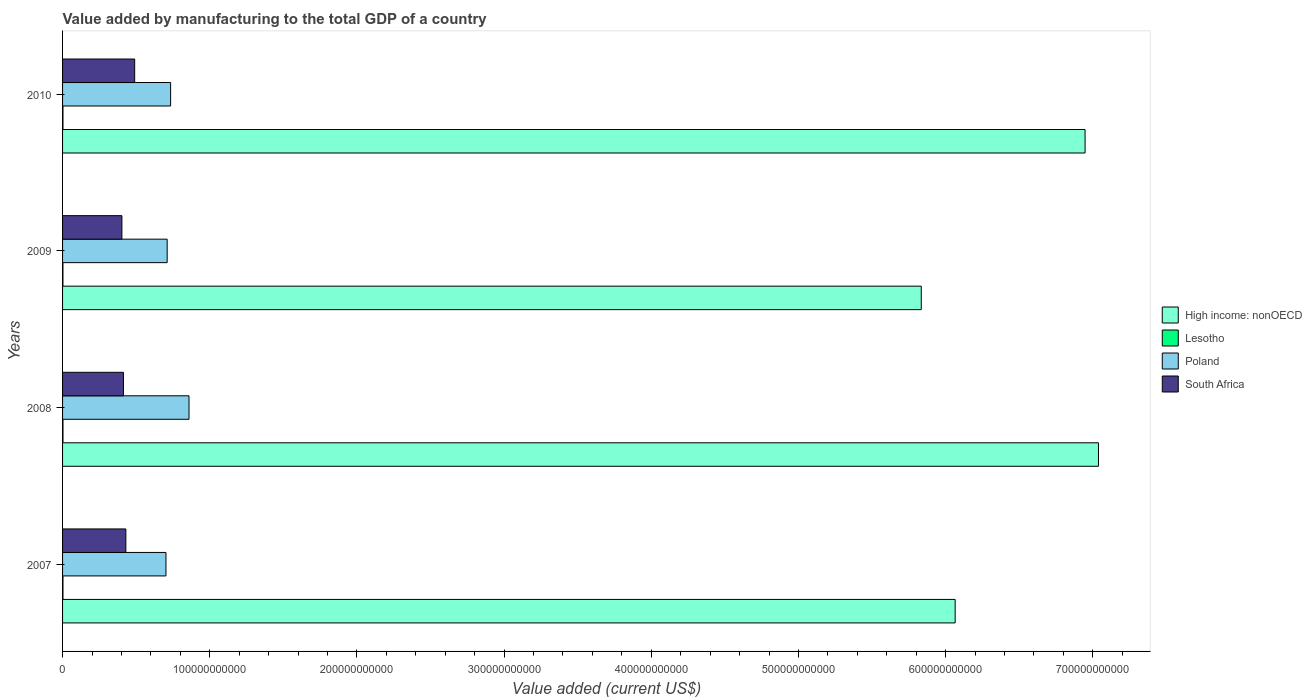How many groups of bars are there?
Make the answer very short. 4. Are the number of bars on each tick of the Y-axis equal?
Your answer should be compact. Yes. In how many cases, is the number of bars for a given year not equal to the number of legend labels?
Give a very brief answer. 0. What is the value added by manufacturing to the total GDP in South Africa in 2008?
Your response must be concise. 4.14e+1. Across all years, what is the maximum value added by manufacturing to the total GDP in High income: nonOECD?
Your answer should be very brief. 7.04e+11. Across all years, what is the minimum value added by manufacturing to the total GDP in Lesotho?
Offer a very short reply. 2.50e+08. In which year was the value added by manufacturing to the total GDP in Lesotho minimum?
Your answer should be very brief. 2009. What is the total value added by manufacturing to the total GDP in South Africa in the graph?
Your answer should be very brief. 1.74e+11. What is the difference between the value added by manufacturing to the total GDP in South Africa in 2009 and that in 2010?
Provide a short and direct response. -8.67e+09. What is the difference between the value added by manufacturing to the total GDP in South Africa in 2009 and the value added by manufacturing to the total GDP in High income: nonOECD in 2007?
Ensure brevity in your answer.  -5.66e+11. What is the average value added by manufacturing to the total GDP in Poland per year?
Your answer should be compact. 7.52e+1. In the year 2007, what is the difference between the value added by manufacturing to the total GDP in Poland and value added by manufacturing to the total GDP in Lesotho?
Keep it short and to the point. 7.00e+1. In how many years, is the value added by manufacturing to the total GDP in Poland greater than 500000000000 US$?
Your response must be concise. 0. What is the ratio of the value added by manufacturing to the total GDP in Lesotho in 2007 to that in 2008?
Make the answer very short. 0.98. Is the difference between the value added by manufacturing to the total GDP in Poland in 2008 and 2009 greater than the difference between the value added by manufacturing to the total GDP in Lesotho in 2008 and 2009?
Your answer should be compact. Yes. What is the difference between the highest and the second highest value added by manufacturing to the total GDP in High income: nonOECD?
Your answer should be compact. 9.09e+09. What is the difference between the highest and the lowest value added by manufacturing to the total GDP in High income: nonOECD?
Keep it short and to the point. 1.20e+11. What does the 1st bar from the top in 2007 represents?
Offer a very short reply. South Africa. What does the 2nd bar from the bottom in 2009 represents?
Ensure brevity in your answer.  Lesotho. Is it the case that in every year, the sum of the value added by manufacturing to the total GDP in High income: nonOECD and value added by manufacturing to the total GDP in Lesotho is greater than the value added by manufacturing to the total GDP in South Africa?
Provide a succinct answer. Yes. Are all the bars in the graph horizontal?
Offer a terse response. Yes. How many years are there in the graph?
Offer a very short reply. 4. What is the difference between two consecutive major ticks on the X-axis?
Offer a very short reply. 1.00e+11. Does the graph contain grids?
Your response must be concise. No. Where does the legend appear in the graph?
Provide a short and direct response. Center right. How many legend labels are there?
Make the answer very short. 4. What is the title of the graph?
Your answer should be compact. Value added by manufacturing to the total GDP of a country. What is the label or title of the X-axis?
Your response must be concise. Value added (current US$). What is the Value added (current US$) of High income: nonOECD in 2007?
Give a very brief answer. 6.07e+11. What is the Value added (current US$) in Lesotho in 2007?
Offer a very short reply. 2.78e+08. What is the Value added (current US$) of Poland in 2007?
Offer a terse response. 7.03e+1. What is the Value added (current US$) in South Africa in 2007?
Provide a succinct answer. 4.30e+1. What is the Value added (current US$) in High income: nonOECD in 2008?
Provide a succinct answer. 7.04e+11. What is the Value added (current US$) in Lesotho in 2008?
Provide a short and direct response. 2.85e+08. What is the Value added (current US$) of Poland in 2008?
Offer a very short reply. 8.59e+1. What is the Value added (current US$) in South Africa in 2008?
Offer a very short reply. 4.14e+1. What is the Value added (current US$) of High income: nonOECD in 2009?
Ensure brevity in your answer.  5.83e+11. What is the Value added (current US$) in Lesotho in 2009?
Give a very brief answer. 2.50e+08. What is the Value added (current US$) in Poland in 2009?
Your answer should be very brief. 7.11e+1. What is the Value added (current US$) of South Africa in 2009?
Ensure brevity in your answer.  4.03e+1. What is the Value added (current US$) of High income: nonOECD in 2010?
Give a very brief answer. 6.95e+11. What is the Value added (current US$) in Lesotho in 2010?
Offer a terse response. 2.76e+08. What is the Value added (current US$) in Poland in 2010?
Ensure brevity in your answer.  7.34e+1. What is the Value added (current US$) of South Africa in 2010?
Ensure brevity in your answer.  4.90e+1. Across all years, what is the maximum Value added (current US$) in High income: nonOECD?
Offer a terse response. 7.04e+11. Across all years, what is the maximum Value added (current US$) in Lesotho?
Provide a short and direct response. 2.85e+08. Across all years, what is the maximum Value added (current US$) of Poland?
Provide a succinct answer. 8.59e+1. Across all years, what is the maximum Value added (current US$) in South Africa?
Make the answer very short. 4.90e+1. Across all years, what is the minimum Value added (current US$) of High income: nonOECD?
Give a very brief answer. 5.83e+11. Across all years, what is the minimum Value added (current US$) in Lesotho?
Your response must be concise. 2.50e+08. Across all years, what is the minimum Value added (current US$) in Poland?
Offer a very short reply. 7.03e+1. Across all years, what is the minimum Value added (current US$) of South Africa?
Keep it short and to the point. 4.03e+1. What is the total Value added (current US$) of High income: nonOECD in the graph?
Keep it short and to the point. 2.59e+12. What is the total Value added (current US$) in Lesotho in the graph?
Your response must be concise. 1.09e+09. What is the total Value added (current US$) of Poland in the graph?
Your answer should be very brief. 3.01e+11. What is the total Value added (current US$) in South Africa in the graph?
Offer a very short reply. 1.74e+11. What is the difference between the Value added (current US$) of High income: nonOECD in 2007 and that in 2008?
Provide a succinct answer. -9.74e+1. What is the difference between the Value added (current US$) of Lesotho in 2007 and that in 2008?
Ensure brevity in your answer.  -6.76e+06. What is the difference between the Value added (current US$) of Poland in 2007 and that in 2008?
Make the answer very short. -1.57e+1. What is the difference between the Value added (current US$) in South Africa in 2007 and that in 2008?
Offer a very short reply. 1.64e+09. What is the difference between the Value added (current US$) of High income: nonOECD in 2007 and that in 2009?
Your answer should be compact. 2.30e+1. What is the difference between the Value added (current US$) of Lesotho in 2007 and that in 2009?
Ensure brevity in your answer.  2.79e+07. What is the difference between the Value added (current US$) of Poland in 2007 and that in 2009?
Your answer should be very brief. -8.25e+08. What is the difference between the Value added (current US$) in South Africa in 2007 and that in 2009?
Your answer should be compact. 2.69e+09. What is the difference between the Value added (current US$) of High income: nonOECD in 2007 and that in 2010?
Make the answer very short. -8.83e+1. What is the difference between the Value added (current US$) of Lesotho in 2007 and that in 2010?
Give a very brief answer. 1.99e+06. What is the difference between the Value added (current US$) of Poland in 2007 and that in 2010?
Keep it short and to the point. -3.16e+09. What is the difference between the Value added (current US$) of South Africa in 2007 and that in 2010?
Provide a succinct answer. -5.99e+09. What is the difference between the Value added (current US$) of High income: nonOECD in 2008 and that in 2009?
Make the answer very short. 1.20e+11. What is the difference between the Value added (current US$) in Lesotho in 2008 and that in 2009?
Give a very brief answer. 3.47e+07. What is the difference between the Value added (current US$) in Poland in 2008 and that in 2009?
Offer a very short reply. 1.48e+1. What is the difference between the Value added (current US$) in South Africa in 2008 and that in 2009?
Make the answer very short. 1.04e+09. What is the difference between the Value added (current US$) of High income: nonOECD in 2008 and that in 2010?
Offer a very short reply. 9.09e+09. What is the difference between the Value added (current US$) of Lesotho in 2008 and that in 2010?
Offer a very short reply. 8.75e+06. What is the difference between the Value added (current US$) of Poland in 2008 and that in 2010?
Your response must be concise. 1.25e+1. What is the difference between the Value added (current US$) of South Africa in 2008 and that in 2010?
Keep it short and to the point. -7.63e+09. What is the difference between the Value added (current US$) of High income: nonOECD in 2009 and that in 2010?
Make the answer very short. -1.11e+11. What is the difference between the Value added (current US$) in Lesotho in 2009 and that in 2010?
Provide a short and direct response. -2.59e+07. What is the difference between the Value added (current US$) of Poland in 2009 and that in 2010?
Keep it short and to the point. -2.33e+09. What is the difference between the Value added (current US$) of South Africa in 2009 and that in 2010?
Keep it short and to the point. -8.67e+09. What is the difference between the Value added (current US$) of High income: nonOECD in 2007 and the Value added (current US$) of Lesotho in 2008?
Make the answer very short. 6.06e+11. What is the difference between the Value added (current US$) of High income: nonOECD in 2007 and the Value added (current US$) of Poland in 2008?
Offer a very short reply. 5.21e+11. What is the difference between the Value added (current US$) in High income: nonOECD in 2007 and the Value added (current US$) in South Africa in 2008?
Provide a succinct answer. 5.65e+11. What is the difference between the Value added (current US$) in Lesotho in 2007 and the Value added (current US$) in Poland in 2008?
Make the answer very short. -8.56e+1. What is the difference between the Value added (current US$) of Lesotho in 2007 and the Value added (current US$) of South Africa in 2008?
Ensure brevity in your answer.  -4.11e+1. What is the difference between the Value added (current US$) in Poland in 2007 and the Value added (current US$) in South Africa in 2008?
Provide a succinct answer. 2.89e+1. What is the difference between the Value added (current US$) of High income: nonOECD in 2007 and the Value added (current US$) of Lesotho in 2009?
Provide a succinct answer. 6.06e+11. What is the difference between the Value added (current US$) of High income: nonOECD in 2007 and the Value added (current US$) of Poland in 2009?
Provide a short and direct response. 5.35e+11. What is the difference between the Value added (current US$) of High income: nonOECD in 2007 and the Value added (current US$) of South Africa in 2009?
Your answer should be very brief. 5.66e+11. What is the difference between the Value added (current US$) in Lesotho in 2007 and the Value added (current US$) in Poland in 2009?
Provide a short and direct response. -7.08e+1. What is the difference between the Value added (current US$) of Lesotho in 2007 and the Value added (current US$) of South Africa in 2009?
Keep it short and to the point. -4.00e+1. What is the difference between the Value added (current US$) in Poland in 2007 and the Value added (current US$) in South Africa in 2009?
Your response must be concise. 2.99e+1. What is the difference between the Value added (current US$) in High income: nonOECD in 2007 and the Value added (current US$) in Lesotho in 2010?
Offer a very short reply. 6.06e+11. What is the difference between the Value added (current US$) of High income: nonOECD in 2007 and the Value added (current US$) of Poland in 2010?
Your answer should be very brief. 5.33e+11. What is the difference between the Value added (current US$) in High income: nonOECD in 2007 and the Value added (current US$) in South Africa in 2010?
Provide a succinct answer. 5.58e+11. What is the difference between the Value added (current US$) of Lesotho in 2007 and the Value added (current US$) of Poland in 2010?
Provide a short and direct response. -7.31e+1. What is the difference between the Value added (current US$) in Lesotho in 2007 and the Value added (current US$) in South Africa in 2010?
Provide a short and direct response. -4.87e+1. What is the difference between the Value added (current US$) of Poland in 2007 and the Value added (current US$) of South Africa in 2010?
Provide a short and direct response. 2.13e+1. What is the difference between the Value added (current US$) in High income: nonOECD in 2008 and the Value added (current US$) in Lesotho in 2009?
Your answer should be compact. 7.04e+11. What is the difference between the Value added (current US$) in High income: nonOECD in 2008 and the Value added (current US$) in Poland in 2009?
Your response must be concise. 6.33e+11. What is the difference between the Value added (current US$) of High income: nonOECD in 2008 and the Value added (current US$) of South Africa in 2009?
Provide a short and direct response. 6.64e+11. What is the difference between the Value added (current US$) of Lesotho in 2008 and the Value added (current US$) of Poland in 2009?
Your answer should be compact. -7.08e+1. What is the difference between the Value added (current US$) of Lesotho in 2008 and the Value added (current US$) of South Africa in 2009?
Offer a terse response. -4.00e+1. What is the difference between the Value added (current US$) in Poland in 2008 and the Value added (current US$) in South Africa in 2009?
Your response must be concise. 4.56e+1. What is the difference between the Value added (current US$) of High income: nonOECD in 2008 and the Value added (current US$) of Lesotho in 2010?
Provide a short and direct response. 7.04e+11. What is the difference between the Value added (current US$) of High income: nonOECD in 2008 and the Value added (current US$) of Poland in 2010?
Provide a succinct answer. 6.30e+11. What is the difference between the Value added (current US$) of High income: nonOECD in 2008 and the Value added (current US$) of South Africa in 2010?
Provide a short and direct response. 6.55e+11. What is the difference between the Value added (current US$) in Lesotho in 2008 and the Value added (current US$) in Poland in 2010?
Your answer should be very brief. -7.31e+1. What is the difference between the Value added (current US$) of Lesotho in 2008 and the Value added (current US$) of South Africa in 2010?
Offer a terse response. -4.87e+1. What is the difference between the Value added (current US$) of Poland in 2008 and the Value added (current US$) of South Africa in 2010?
Offer a terse response. 3.69e+1. What is the difference between the Value added (current US$) in High income: nonOECD in 2009 and the Value added (current US$) in Lesotho in 2010?
Provide a succinct answer. 5.83e+11. What is the difference between the Value added (current US$) in High income: nonOECD in 2009 and the Value added (current US$) in Poland in 2010?
Offer a very short reply. 5.10e+11. What is the difference between the Value added (current US$) of High income: nonOECD in 2009 and the Value added (current US$) of South Africa in 2010?
Ensure brevity in your answer.  5.34e+11. What is the difference between the Value added (current US$) of Lesotho in 2009 and the Value added (current US$) of Poland in 2010?
Provide a short and direct response. -7.32e+1. What is the difference between the Value added (current US$) of Lesotho in 2009 and the Value added (current US$) of South Africa in 2010?
Offer a very short reply. -4.87e+1. What is the difference between the Value added (current US$) of Poland in 2009 and the Value added (current US$) of South Africa in 2010?
Keep it short and to the point. 2.21e+1. What is the average Value added (current US$) of High income: nonOECD per year?
Offer a terse response. 6.47e+11. What is the average Value added (current US$) in Lesotho per year?
Give a very brief answer. 2.72e+08. What is the average Value added (current US$) of Poland per year?
Offer a very short reply. 7.52e+1. What is the average Value added (current US$) of South Africa per year?
Ensure brevity in your answer.  4.34e+1. In the year 2007, what is the difference between the Value added (current US$) of High income: nonOECD and Value added (current US$) of Lesotho?
Make the answer very short. 6.06e+11. In the year 2007, what is the difference between the Value added (current US$) in High income: nonOECD and Value added (current US$) in Poland?
Your answer should be very brief. 5.36e+11. In the year 2007, what is the difference between the Value added (current US$) of High income: nonOECD and Value added (current US$) of South Africa?
Provide a short and direct response. 5.63e+11. In the year 2007, what is the difference between the Value added (current US$) in Lesotho and Value added (current US$) in Poland?
Provide a short and direct response. -7.00e+1. In the year 2007, what is the difference between the Value added (current US$) in Lesotho and Value added (current US$) in South Africa?
Your response must be concise. -4.27e+1. In the year 2007, what is the difference between the Value added (current US$) in Poland and Value added (current US$) in South Africa?
Keep it short and to the point. 2.73e+1. In the year 2008, what is the difference between the Value added (current US$) in High income: nonOECD and Value added (current US$) in Lesotho?
Ensure brevity in your answer.  7.04e+11. In the year 2008, what is the difference between the Value added (current US$) in High income: nonOECD and Value added (current US$) in Poland?
Provide a succinct answer. 6.18e+11. In the year 2008, what is the difference between the Value added (current US$) of High income: nonOECD and Value added (current US$) of South Africa?
Offer a very short reply. 6.63e+11. In the year 2008, what is the difference between the Value added (current US$) in Lesotho and Value added (current US$) in Poland?
Make the answer very short. -8.56e+1. In the year 2008, what is the difference between the Value added (current US$) of Lesotho and Value added (current US$) of South Africa?
Keep it short and to the point. -4.11e+1. In the year 2008, what is the difference between the Value added (current US$) of Poland and Value added (current US$) of South Africa?
Your response must be concise. 4.46e+1. In the year 2009, what is the difference between the Value added (current US$) of High income: nonOECD and Value added (current US$) of Lesotho?
Provide a short and direct response. 5.83e+11. In the year 2009, what is the difference between the Value added (current US$) in High income: nonOECD and Value added (current US$) in Poland?
Your answer should be very brief. 5.12e+11. In the year 2009, what is the difference between the Value added (current US$) in High income: nonOECD and Value added (current US$) in South Africa?
Ensure brevity in your answer.  5.43e+11. In the year 2009, what is the difference between the Value added (current US$) in Lesotho and Value added (current US$) in Poland?
Provide a short and direct response. -7.08e+1. In the year 2009, what is the difference between the Value added (current US$) in Lesotho and Value added (current US$) in South Africa?
Your answer should be compact. -4.01e+1. In the year 2009, what is the difference between the Value added (current US$) in Poland and Value added (current US$) in South Africa?
Provide a succinct answer. 3.08e+1. In the year 2010, what is the difference between the Value added (current US$) in High income: nonOECD and Value added (current US$) in Lesotho?
Offer a terse response. 6.94e+11. In the year 2010, what is the difference between the Value added (current US$) in High income: nonOECD and Value added (current US$) in Poland?
Your answer should be very brief. 6.21e+11. In the year 2010, what is the difference between the Value added (current US$) of High income: nonOECD and Value added (current US$) of South Africa?
Keep it short and to the point. 6.46e+11. In the year 2010, what is the difference between the Value added (current US$) of Lesotho and Value added (current US$) of Poland?
Provide a short and direct response. -7.31e+1. In the year 2010, what is the difference between the Value added (current US$) in Lesotho and Value added (current US$) in South Africa?
Offer a very short reply. -4.87e+1. In the year 2010, what is the difference between the Value added (current US$) in Poland and Value added (current US$) in South Africa?
Offer a very short reply. 2.44e+1. What is the ratio of the Value added (current US$) in High income: nonOECD in 2007 to that in 2008?
Keep it short and to the point. 0.86. What is the ratio of the Value added (current US$) of Lesotho in 2007 to that in 2008?
Ensure brevity in your answer.  0.98. What is the ratio of the Value added (current US$) in Poland in 2007 to that in 2008?
Offer a very short reply. 0.82. What is the ratio of the Value added (current US$) in South Africa in 2007 to that in 2008?
Give a very brief answer. 1.04. What is the ratio of the Value added (current US$) of High income: nonOECD in 2007 to that in 2009?
Offer a very short reply. 1.04. What is the ratio of the Value added (current US$) of Lesotho in 2007 to that in 2009?
Ensure brevity in your answer.  1.11. What is the ratio of the Value added (current US$) of Poland in 2007 to that in 2009?
Your answer should be very brief. 0.99. What is the ratio of the Value added (current US$) in South Africa in 2007 to that in 2009?
Keep it short and to the point. 1.07. What is the ratio of the Value added (current US$) of High income: nonOECD in 2007 to that in 2010?
Give a very brief answer. 0.87. What is the ratio of the Value added (current US$) in Lesotho in 2007 to that in 2010?
Your answer should be very brief. 1.01. What is the ratio of the Value added (current US$) of South Africa in 2007 to that in 2010?
Your answer should be compact. 0.88. What is the ratio of the Value added (current US$) of High income: nonOECD in 2008 to that in 2009?
Offer a very short reply. 1.21. What is the ratio of the Value added (current US$) of Lesotho in 2008 to that in 2009?
Your response must be concise. 1.14. What is the ratio of the Value added (current US$) in Poland in 2008 to that in 2009?
Provide a short and direct response. 1.21. What is the ratio of the Value added (current US$) of South Africa in 2008 to that in 2009?
Your response must be concise. 1.03. What is the ratio of the Value added (current US$) in High income: nonOECD in 2008 to that in 2010?
Your response must be concise. 1.01. What is the ratio of the Value added (current US$) of Lesotho in 2008 to that in 2010?
Keep it short and to the point. 1.03. What is the ratio of the Value added (current US$) of Poland in 2008 to that in 2010?
Offer a terse response. 1.17. What is the ratio of the Value added (current US$) of South Africa in 2008 to that in 2010?
Offer a terse response. 0.84. What is the ratio of the Value added (current US$) of High income: nonOECD in 2009 to that in 2010?
Your response must be concise. 0.84. What is the ratio of the Value added (current US$) of Lesotho in 2009 to that in 2010?
Give a very brief answer. 0.91. What is the ratio of the Value added (current US$) in Poland in 2009 to that in 2010?
Make the answer very short. 0.97. What is the ratio of the Value added (current US$) of South Africa in 2009 to that in 2010?
Keep it short and to the point. 0.82. What is the difference between the highest and the second highest Value added (current US$) of High income: nonOECD?
Your answer should be very brief. 9.09e+09. What is the difference between the highest and the second highest Value added (current US$) of Lesotho?
Your answer should be very brief. 6.76e+06. What is the difference between the highest and the second highest Value added (current US$) in Poland?
Give a very brief answer. 1.25e+1. What is the difference between the highest and the second highest Value added (current US$) in South Africa?
Ensure brevity in your answer.  5.99e+09. What is the difference between the highest and the lowest Value added (current US$) of High income: nonOECD?
Offer a very short reply. 1.20e+11. What is the difference between the highest and the lowest Value added (current US$) of Lesotho?
Your answer should be compact. 3.47e+07. What is the difference between the highest and the lowest Value added (current US$) in Poland?
Give a very brief answer. 1.57e+1. What is the difference between the highest and the lowest Value added (current US$) in South Africa?
Offer a very short reply. 8.67e+09. 